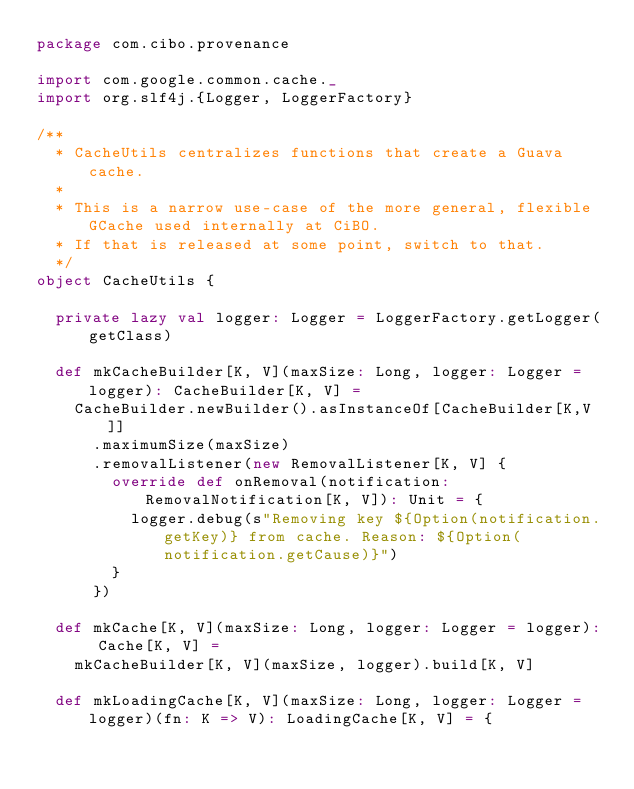<code> <loc_0><loc_0><loc_500><loc_500><_Scala_>package com.cibo.provenance

import com.google.common.cache._
import org.slf4j.{Logger, LoggerFactory}

/**
  * CacheUtils centralizes functions that create a Guava cache.
  *
  * This is a narrow use-case of the more general, flexible GCache used internally at CiBO.
  * If that is released at some point, switch to that.
  */
object CacheUtils {

  private lazy val logger: Logger = LoggerFactory.getLogger(getClass)

  def mkCacheBuilder[K, V](maxSize: Long, logger: Logger = logger): CacheBuilder[K, V] =
    CacheBuilder.newBuilder().asInstanceOf[CacheBuilder[K,V]]
      .maximumSize(maxSize)
      .removalListener(new RemovalListener[K, V] {
        override def onRemoval(notification: RemovalNotification[K, V]): Unit = {
          logger.debug(s"Removing key ${Option(notification.getKey)} from cache. Reason: ${Option(notification.getCause)}")
        }
      })

  def mkCache[K, V](maxSize: Long, logger: Logger = logger): Cache[K, V] =
    mkCacheBuilder[K, V](maxSize, logger).build[K, V]

  def mkLoadingCache[K, V](maxSize: Long, logger: Logger = logger)(fn: K => V): LoadingCache[K, V] = {</code> 